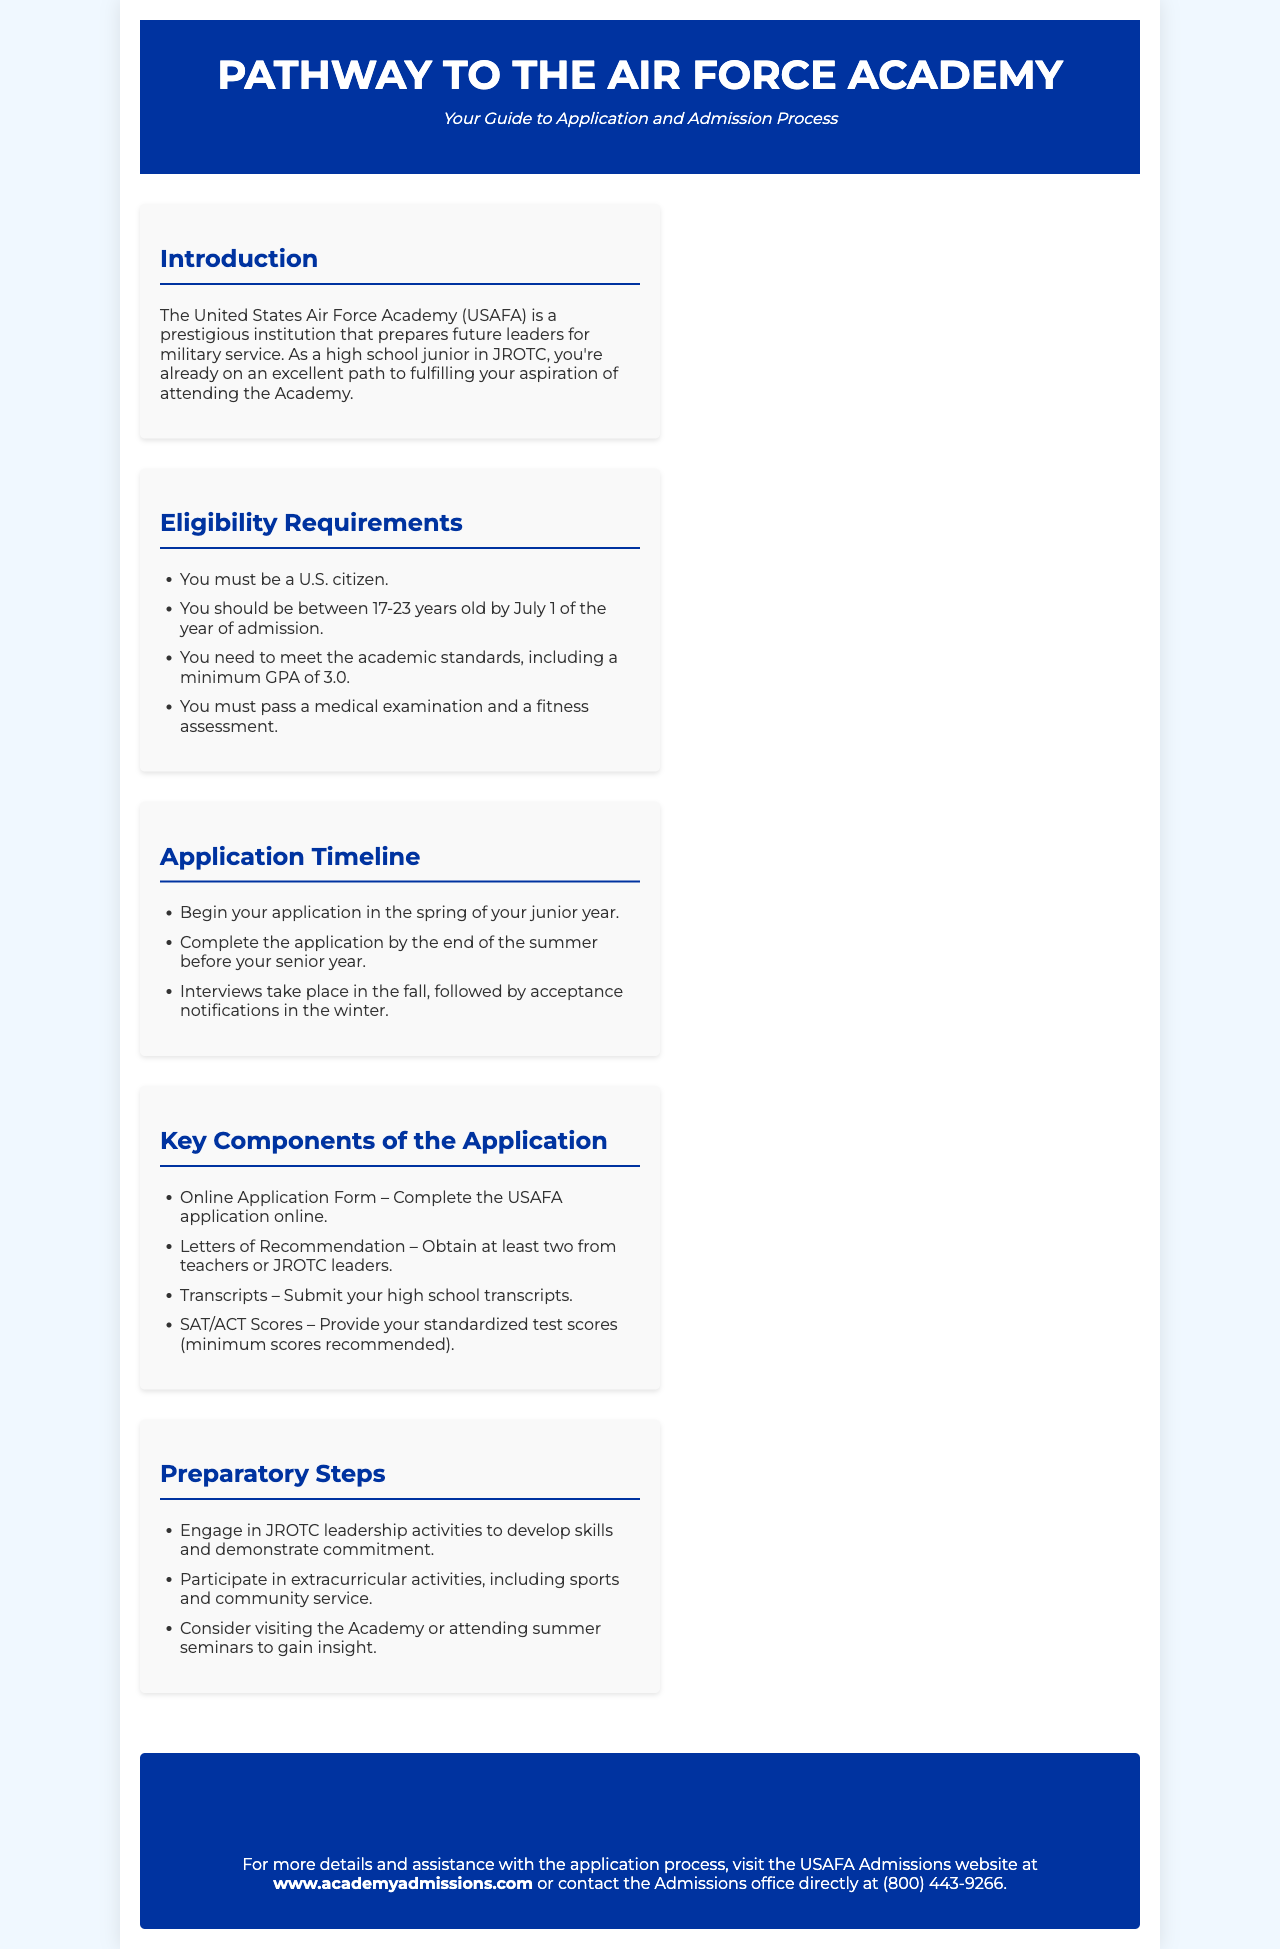What is the minimum GPA required? The minimum GPA is stated as one of the eligibility requirements in the document.
Answer: 3.0 What age range must applicants fall within? The eligibility requirements specify the age range for applicants.
Answer: 17-23 years old When should you begin your application? The application timeline includes the timeframe for starting the application process.
Answer: Spring of your junior year What is one of the key components of the application? The sections mention several parts that are essential to the application process.
Answer: Online Application Form What is the contact number for the Admissions office? The document provides the contact information for assistance with the application process.
Answer: (800) 443-9266 What is one preparatory step suggested in the brochure? The document lists actions that can help applicants prepare for the Academy.
Answer: Engage in JROTC leadership activities What type of recommendations are needed? The key components section specifies what types of letters are required in the application.
Answer: Letters of Recommendation What is the website for more details? The contact information section includes a URL for further assistance.
Answer: www.academyadmissions.com What season do acceptance notifications occur? The application timeline outlines when candidates can expect to hear back regarding their application status.
Answer: Winter 